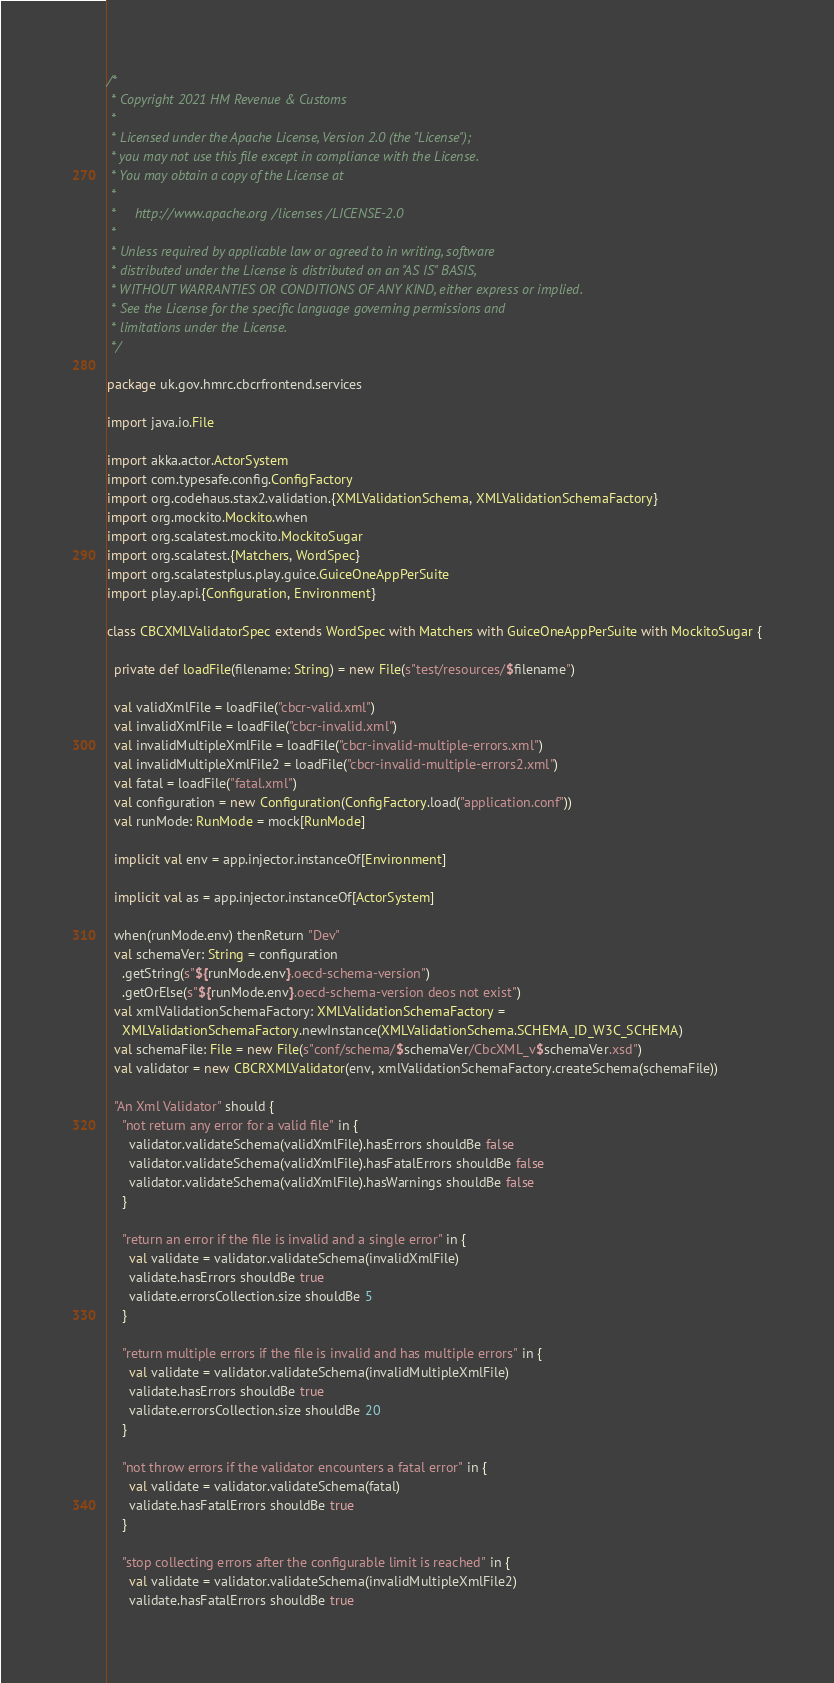Convert code to text. <code><loc_0><loc_0><loc_500><loc_500><_Scala_>/*
 * Copyright 2021 HM Revenue & Customs
 *
 * Licensed under the Apache License, Version 2.0 (the "License");
 * you may not use this file except in compliance with the License.
 * You may obtain a copy of the License at
 *
 *     http://www.apache.org/licenses/LICENSE-2.0
 *
 * Unless required by applicable law or agreed to in writing, software
 * distributed under the License is distributed on an "AS IS" BASIS,
 * WITHOUT WARRANTIES OR CONDITIONS OF ANY KIND, either express or implied.
 * See the License for the specific language governing permissions and
 * limitations under the License.
 */

package uk.gov.hmrc.cbcrfrontend.services

import java.io.File

import akka.actor.ActorSystem
import com.typesafe.config.ConfigFactory
import org.codehaus.stax2.validation.{XMLValidationSchema, XMLValidationSchemaFactory}
import org.mockito.Mockito.when
import org.scalatest.mockito.MockitoSugar
import org.scalatest.{Matchers, WordSpec}
import org.scalatestplus.play.guice.GuiceOneAppPerSuite
import play.api.{Configuration, Environment}

class CBCXMLValidatorSpec extends WordSpec with Matchers with GuiceOneAppPerSuite with MockitoSugar {

  private def loadFile(filename: String) = new File(s"test/resources/$filename")

  val validXmlFile = loadFile("cbcr-valid.xml")
  val invalidXmlFile = loadFile("cbcr-invalid.xml")
  val invalidMultipleXmlFile = loadFile("cbcr-invalid-multiple-errors.xml")
  val invalidMultipleXmlFile2 = loadFile("cbcr-invalid-multiple-errors2.xml")
  val fatal = loadFile("fatal.xml")
  val configuration = new Configuration(ConfigFactory.load("application.conf"))
  val runMode: RunMode = mock[RunMode]

  implicit val env = app.injector.instanceOf[Environment]

  implicit val as = app.injector.instanceOf[ActorSystem]

  when(runMode.env) thenReturn "Dev"
  val schemaVer: String = configuration
    .getString(s"${runMode.env}.oecd-schema-version")
    .getOrElse(s"${runMode.env}.oecd-schema-version deos not exist")
  val xmlValidationSchemaFactory: XMLValidationSchemaFactory =
    XMLValidationSchemaFactory.newInstance(XMLValidationSchema.SCHEMA_ID_W3C_SCHEMA)
  val schemaFile: File = new File(s"conf/schema/$schemaVer/CbcXML_v$schemaVer.xsd")
  val validator = new CBCRXMLValidator(env, xmlValidationSchemaFactory.createSchema(schemaFile))

  "An Xml Validator" should {
    "not return any error for a valid file" in {
      validator.validateSchema(validXmlFile).hasErrors shouldBe false
      validator.validateSchema(validXmlFile).hasFatalErrors shouldBe false
      validator.validateSchema(validXmlFile).hasWarnings shouldBe false
    }

    "return an error if the file is invalid and a single error" in {
      val validate = validator.validateSchema(invalidXmlFile)
      validate.hasErrors shouldBe true
      validate.errorsCollection.size shouldBe 5
    }

    "return multiple errors if the file is invalid and has multiple errors" in {
      val validate = validator.validateSchema(invalidMultipleXmlFile)
      validate.hasErrors shouldBe true
      validate.errorsCollection.size shouldBe 20
    }

    "not throw errors if the validator encounters a fatal error" in {
      val validate = validator.validateSchema(fatal)
      validate.hasFatalErrors shouldBe true
    }

    "stop collecting errors after the configurable limit is reached" in {
      val validate = validator.validateSchema(invalidMultipleXmlFile2)
      validate.hasFatalErrors shouldBe true</code> 